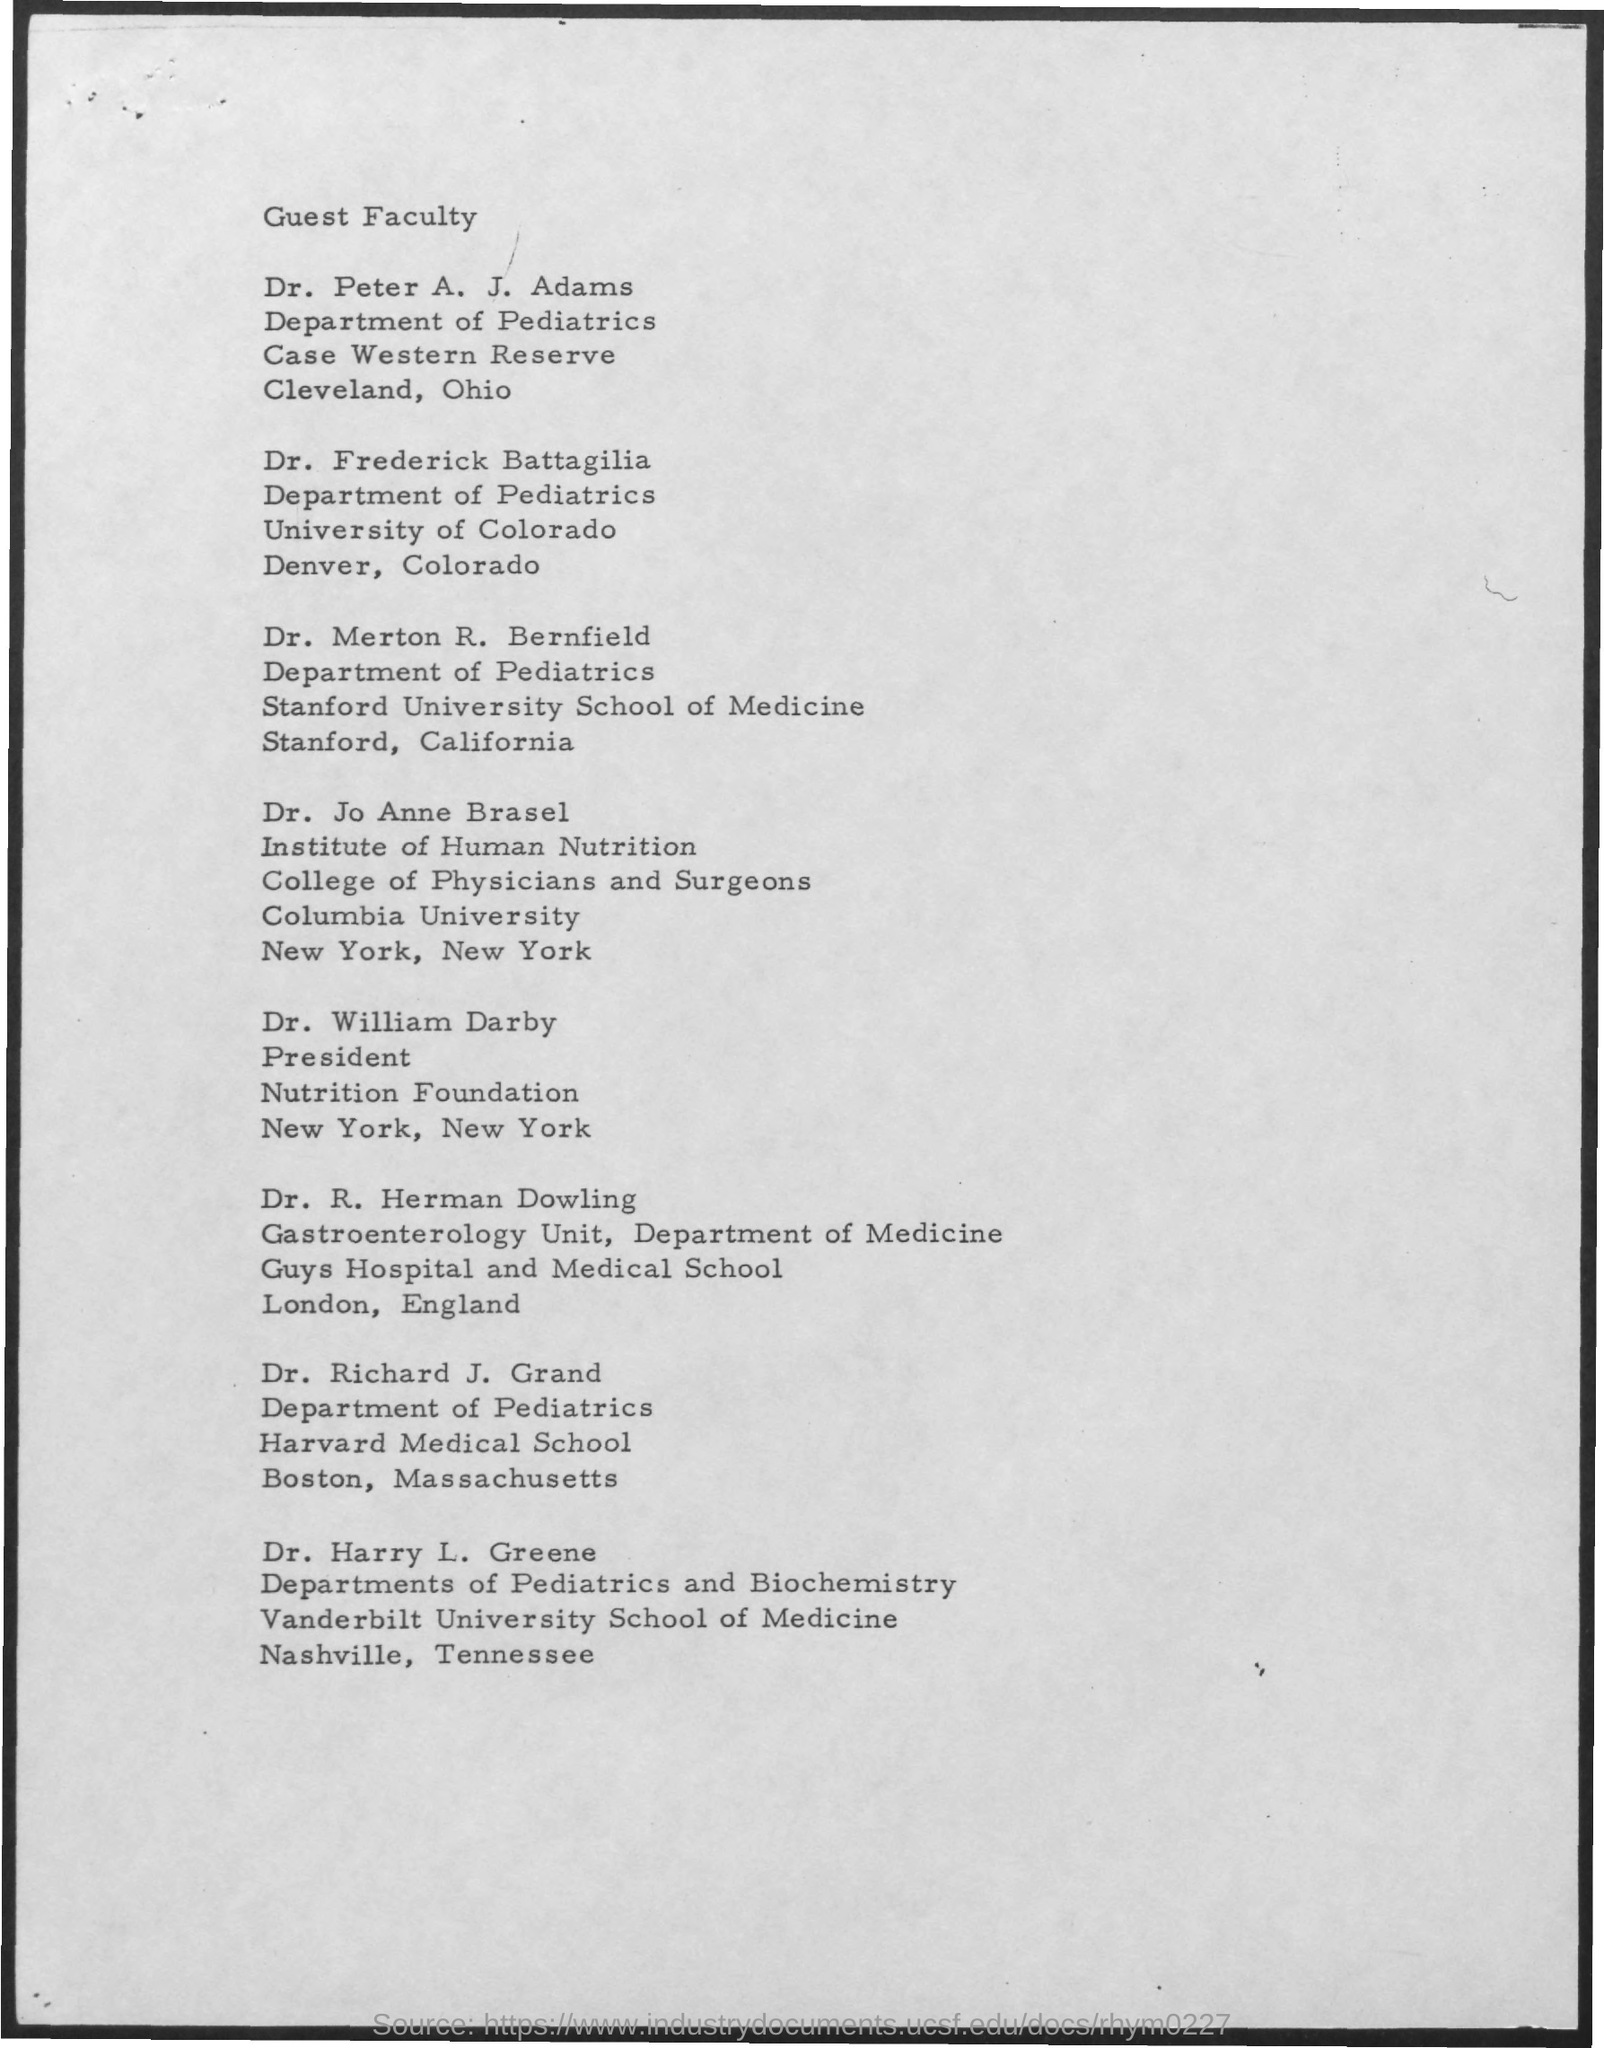Outline some significant characteristics in this image. The first title in the document is 'Guest Faculty.' 